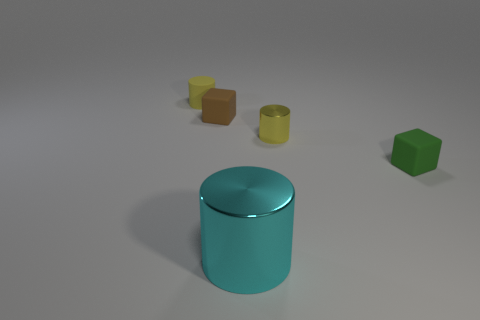There is another block that is the same size as the brown cube; what material is it?
Give a very brief answer. Rubber. Are there more brown things on the left side of the large shiny thing than cyan cylinders that are behind the tiny brown rubber block?
Keep it short and to the point. Yes. Is there a small yellow shiny object of the same shape as the tiny green rubber object?
Ensure brevity in your answer.  No. The brown rubber thing that is the same size as the rubber cylinder is what shape?
Your answer should be compact. Cube. There is a brown thing that is behind the green matte object; what shape is it?
Offer a terse response. Cube. Is the number of things that are behind the yellow metal cylinder less than the number of cyan cylinders that are in front of the big shiny cylinder?
Offer a very short reply. No. There is a brown cube; does it have the same size as the metallic thing in front of the tiny green cube?
Make the answer very short. No. What number of other things have the same size as the green matte object?
Give a very brief answer. 3. There is a cylinder that is the same material as the tiny brown thing; what is its color?
Make the answer very short. Yellow. Are there more small rubber cubes than green objects?
Provide a short and direct response. Yes. 